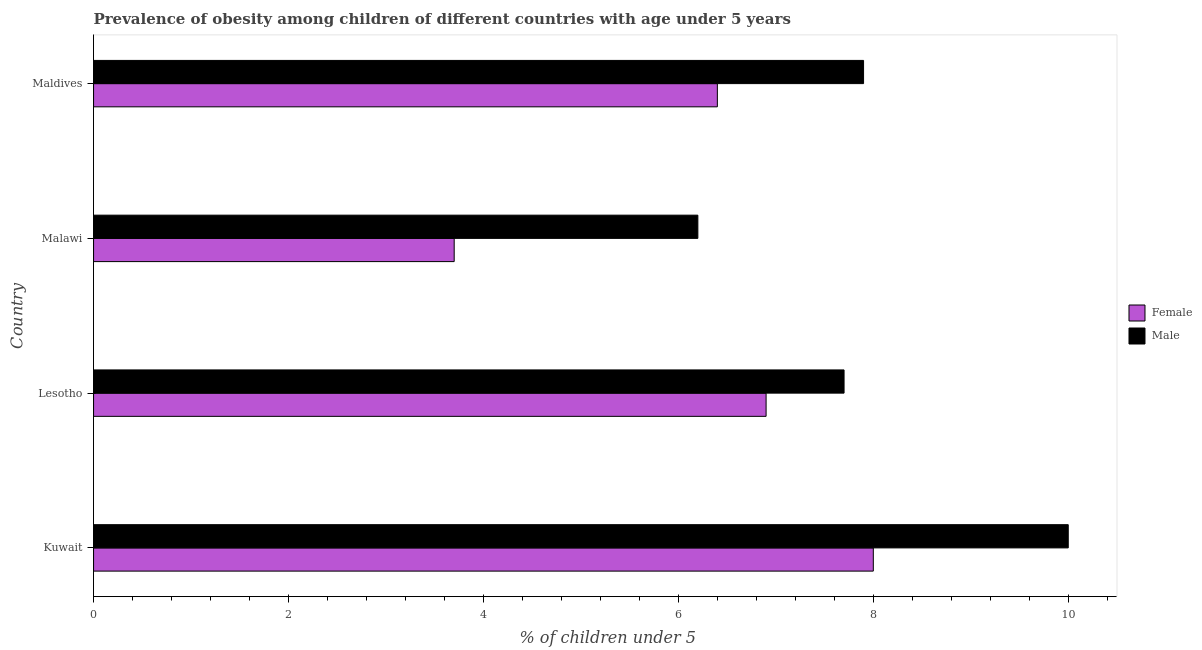Are the number of bars on each tick of the Y-axis equal?
Your response must be concise. Yes. How many bars are there on the 2nd tick from the top?
Ensure brevity in your answer.  2. What is the label of the 4th group of bars from the top?
Offer a terse response. Kuwait. In how many cases, is the number of bars for a given country not equal to the number of legend labels?
Provide a short and direct response. 0. What is the percentage of obese male children in Lesotho?
Provide a succinct answer. 7.7. Across all countries, what is the maximum percentage of obese male children?
Ensure brevity in your answer.  10. Across all countries, what is the minimum percentage of obese female children?
Make the answer very short. 3.7. In which country was the percentage of obese male children maximum?
Your response must be concise. Kuwait. In which country was the percentage of obese male children minimum?
Provide a short and direct response. Malawi. What is the total percentage of obese female children in the graph?
Your answer should be compact. 25. What is the difference between the percentage of obese female children in Kuwait and the percentage of obese male children in Lesotho?
Offer a terse response. 0.3. What is the average percentage of obese female children per country?
Make the answer very short. 6.25. What is the ratio of the percentage of obese female children in Lesotho to that in Maldives?
Your answer should be compact. 1.08. What is the difference between the highest and the second highest percentage of obese female children?
Make the answer very short. 1.1. In how many countries, is the percentage of obese female children greater than the average percentage of obese female children taken over all countries?
Give a very brief answer. 3. How many bars are there?
Your response must be concise. 8. Are all the bars in the graph horizontal?
Give a very brief answer. Yes. What is the difference between two consecutive major ticks on the X-axis?
Make the answer very short. 2. Are the values on the major ticks of X-axis written in scientific E-notation?
Offer a very short reply. No. Does the graph contain grids?
Provide a short and direct response. No. How many legend labels are there?
Offer a very short reply. 2. How are the legend labels stacked?
Your answer should be compact. Vertical. What is the title of the graph?
Provide a succinct answer. Prevalence of obesity among children of different countries with age under 5 years. Does "Central government" appear as one of the legend labels in the graph?
Offer a terse response. No. What is the label or title of the X-axis?
Keep it short and to the point.  % of children under 5. What is the  % of children under 5 of Female in Kuwait?
Offer a very short reply. 8. What is the  % of children under 5 of Male in Kuwait?
Provide a succinct answer. 10. What is the  % of children under 5 of Female in Lesotho?
Your answer should be very brief. 6.9. What is the  % of children under 5 of Male in Lesotho?
Offer a terse response. 7.7. What is the  % of children under 5 of Female in Malawi?
Give a very brief answer. 3.7. What is the  % of children under 5 of Male in Malawi?
Ensure brevity in your answer.  6.2. What is the  % of children under 5 in Female in Maldives?
Offer a very short reply. 6.4. What is the  % of children under 5 in Male in Maldives?
Offer a terse response. 7.9. Across all countries, what is the minimum  % of children under 5 in Female?
Your response must be concise. 3.7. Across all countries, what is the minimum  % of children under 5 of Male?
Give a very brief answer. 6.2. What is the total  % of children under 5 in Male in the graph?
Your answer should be very brief. 31.8. What is the difference between the  % of children under 5 in Female in Kuwait and that in Lesotho?
Provide a succinct answer. 1.1. What is the difference between the  % of children under 5 of Male in Kuwait and that in Malawi?
Give a very brief answer. 3.8. What is the difference between the  % of children under 5 in Female in Kuwait and that in Maldives?
Keep it short and to the point. 1.6. What is the difference between the  % of children under 5 in Male in Kuwait and that in Maldives?
Ensure brevity in your answer.  2.1. What is the difference between the  % of children under 5 of Male in Lesotho and that in Maldives?
Your response must be concise. -0.2. What is the difference between the  % of children under 5 of Male in Malawi and that in Maldives?
Make the answer very short. -1.7. What is the difference between the  % of children under 5 in Female in Kuwait and the  % of children under 5 in Male in Lesotho?
Offer a very short reply. 0.3. What is the difference between the  % of children under 5 of Female in Kuwait and the  % of children under 5 of Male in Malawi?
Provide a succinct answer. 1.8. What is the difference between the  % of children under 5 in Female in Kuwait and the  % of children under 5 in Male in Maldives?
Provide a short and direct response. 0.1. What is the difference between the  % of children under 5 in Female in Lesotho and the  % of children under 5 in Male in Malawi?
Give a very brief answer. 0.7. What is the difference between the  % of children under 5 of Female in Malawi and the  % of children under 5 of Male in Maldives?
Your answer should be very brief. -4.2. What is the average  % of children under 5 in Female per country?
Your response must be concise. 6.25. What is the average  % of children under 5 of Male per country?
Provide a succinct answer. 7.95. What is the difference between the  % of children under 5 of Female and  % of children under 5 of Male in Kuwait?
Your answer should be compact. -2. What is the difference between the  % of children under 5 of Female and  % of children under 5 of Male in Malawi?
Make the answer very short. -2.5. What is the difference between the  % of children under 5 in Female and  % of children under 5 in Male in Maldives?
Offer a terse response. -1.5. What is the ratio of the  % of children under 5 in Female in Kuwait to that in Lesotho?
Your answer should be compact. 1.16. What is the ratio of the  % of children under 5 of Male in Kuwait to that in Lesotho?
Make the answer very short. 1.3. What is the ratio of the  % of children under 5 in Female in Kuwait to that in Malawi?
Give a very brief answer. 2.16. What is the ratio of the  % of children under 5 in Male in Kuwait to that in Malawi?
Make the answer very short. 1.61. What is the ratio of the  % of children under 5 of Male in Kuwait to that in Maldives?
Make the answer very short. 1.27. What is the ratio of the  % of children under 5 of Female in Lesotho to that in Malawi?
Offer a terse response. 1.86. What is the ratio of the  % of children under 5 of Male in Lesotho to that in Malawi?
Provide a short and direct response. 1.24. What is the ratio of the  % of children under 5 in Female in Lesotho to that in Maldives?
Provide a short and direct response. 1.08. What is the ratio of the  % of children under 5 of Male in Lesotho to that in Maldives?
Your response must be concise. 0.97. What is the ratio of the  % of children under 5 of Female in Malawi to that in Maldives?
Your response must be concise. 0.58. What is the ratio of the  % of children under 5 of Male in Malawi to that in Maldives?
Provide a short and direct response. 0.78. What is the difference between the highest and the second highest  % of children under 5 in Male?
Give a very brief answer. 2.1. What is the difference between the highest and the lowest  % of children under 5 in Female?
Your answer should be compact. 4.3. What is the difference between the highest and the lowest  % of children under 5 in Male?
Provide a succinct answer. 3.8. 